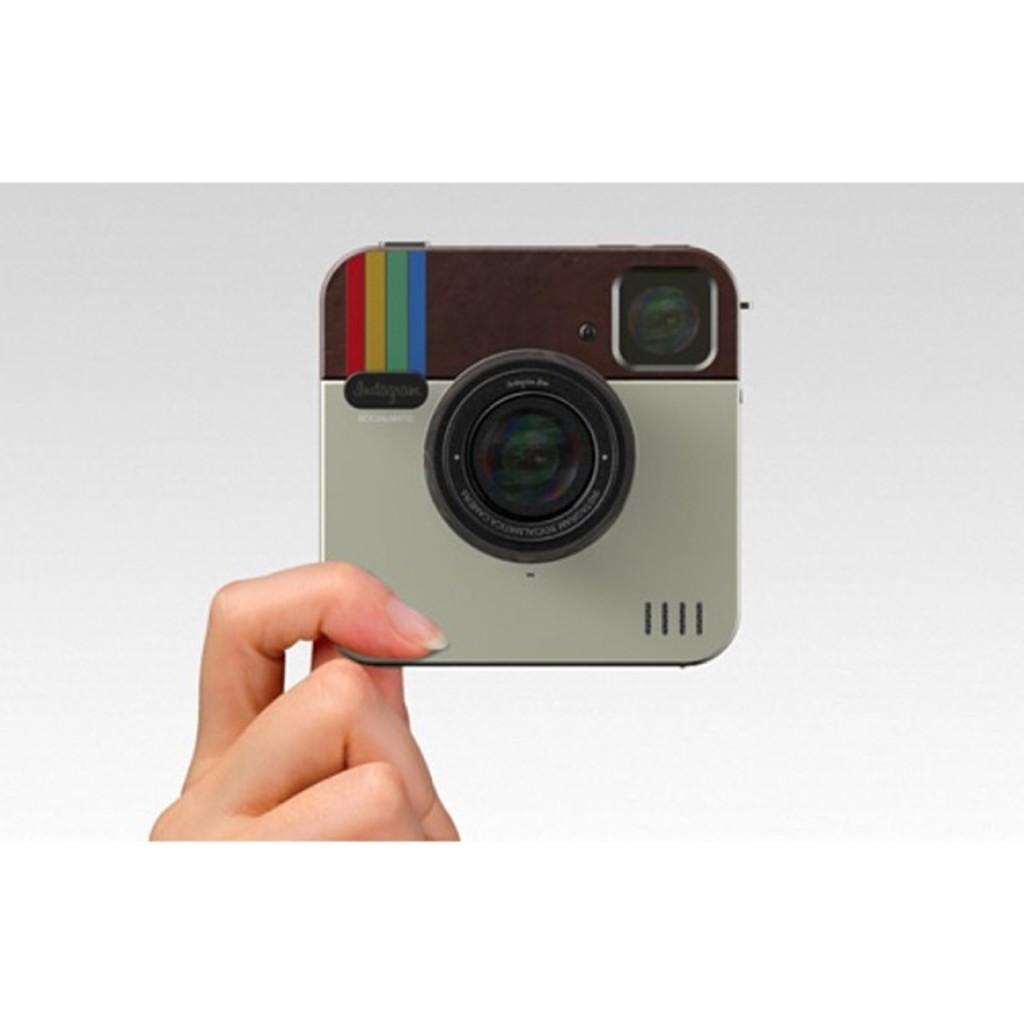What is the person's hand holding in the image? The person's hand is holding an object that appears to be a camera in the image. What can be seen in the background of the image? The background of the image is white. What type of polish is being applied to the camera in the image? There is no indication in the image that any polish is being applied to the camera. 